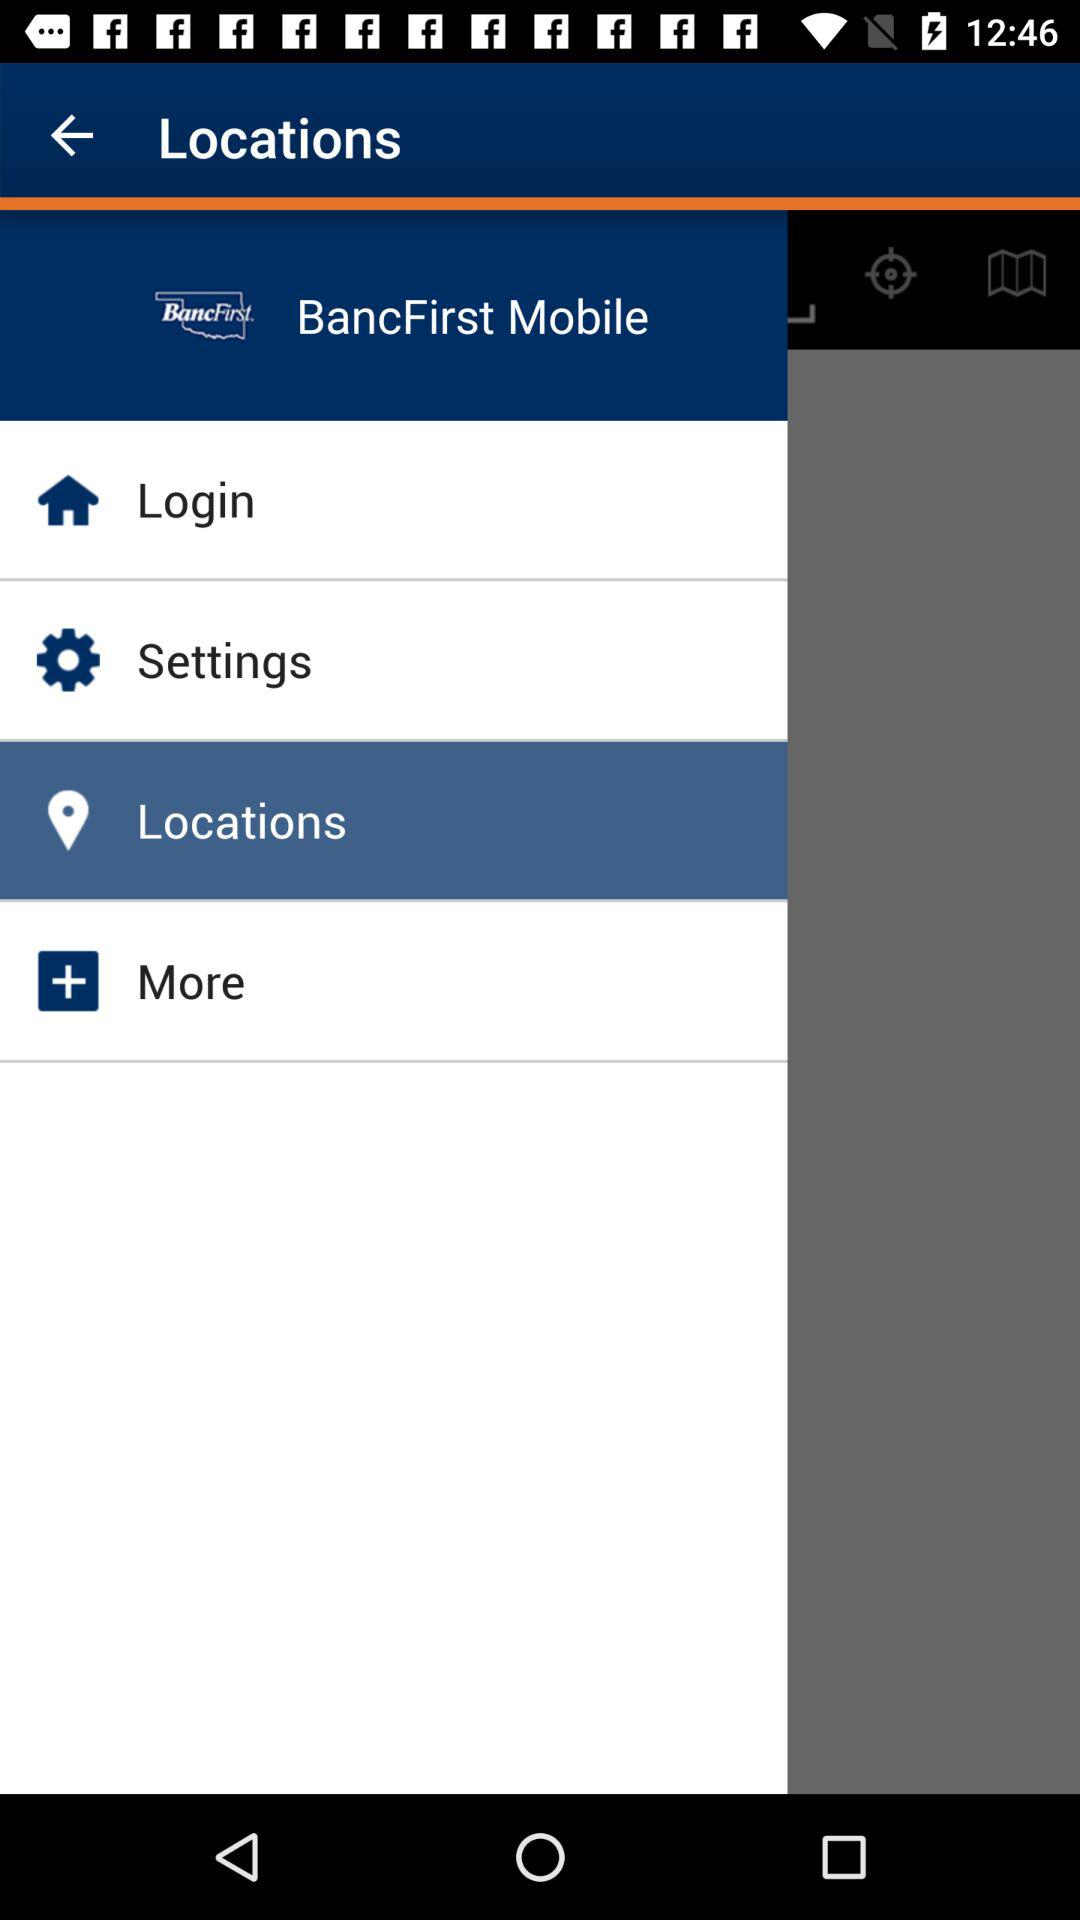What is the name of the application? The name of the application is "BancFirst Mobile". 